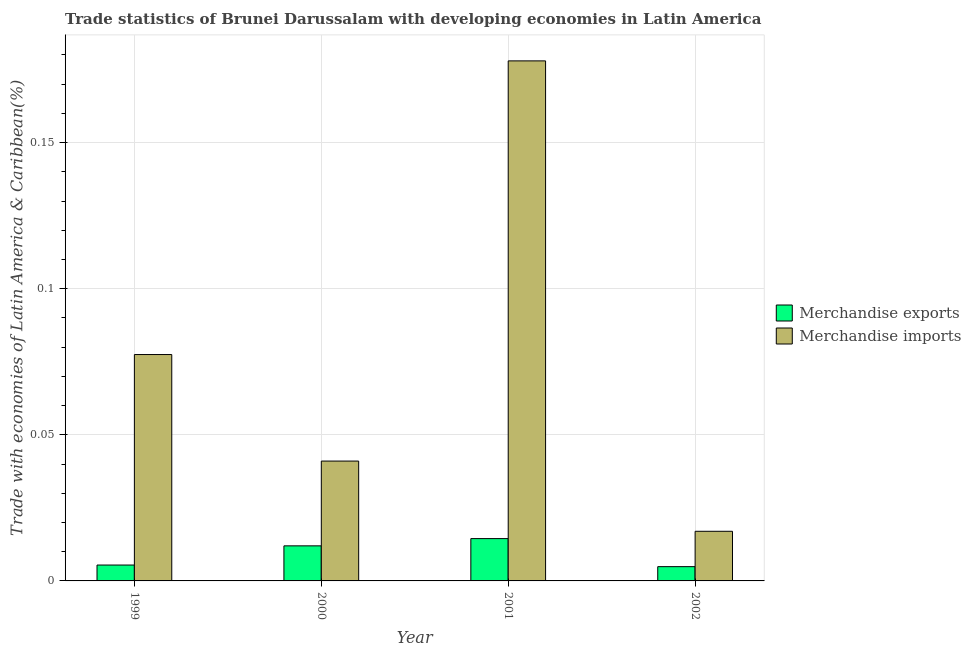How many groups of bars are there?
Give a very brief answer. 4. Are the number of bars per tick equal to the number of legend labels?
Offer a very short reply. Yes. How many bars are there on the 4th tick from the right?
Make the answer very short. 2. What is the label of the 1st group of bars from the left?
Your answer should be very brief. 1999. In how many cases, is the number of bars for a given year not equal to the number of legend labels?
Your response must be concise. 0. What is the merchandise imports in 1999?
Your answer should be very brief. 0.08. Across all years, what is the maximum merchandise exports?
Offer a very short reply. 0.01. Across all years, what is the minimum merchandise exports?
Your answer should be compact. 0. In which year was the merchandise exports minimum?
Give a very brief answer. 2002. What is the total merchandise exports in the graph?
Ensure brevity in your answer.  0.04. What is the difference between the merchandise exports in 2001 and that in 2002?
Provide a succinct answer. 0.01. What is the difference between the merchandise exports in 2001 and the merchandise imports in 1999?
Make the answer very short. 0.01. What is the average merchandise exports per year?
Ensure brevity in your answer.  0.01. In the year 2000, what is the difference between the merchandise imports and merchandise exports?
Provide a succinct answer. 0. In how many years, is the merchandise exports greater than 0.060000000000000005 %?
Keep it short and to the point. 0. What is the ratio of the merchandise imports in 1999 to that in 2000?
Ensure brevity in your answer.  1.89. Is the merchandise imports in 1999 less than that in 2001?
Your answer should be compact. Yes. Is the difference between the merchandise imports in 1999 and 2001 greater than the difference between the merchandise exports in 1999 and 2001?
Your answer should be very brief. No. What is the difference between the highest and the second highest merchandise exports?
Your answer should be compact. 0. What is the difference between the highest and the lowest merchandise imports?
Your response must be concise. 0.16. In how many years, is the merchandise imports greater than the average merchandise imports taken over all years?
Ensure brevity in your answer.  1. How many bars are there?
Ensure brevity in your answer.  8. Are all the bars in the graph horizontal?
Give a very brief answer. No. Are the values on the major ticks of Y-axis written in scientific E-notation?
Your response must be concise. No. Does the graph contain any zero values?
Offer a very short reply. No. Where does the legend appear in the graph?
Give a very brief answer. Center right. How many legend labels are there?
Make the answer very short. 2. What is the title of the graph?
Make the answer very short. Trade statistics of Brunei Darussalam with developing economies in Latin America. Does "Under-5(female)" appear as one of the legend labels in the graph?
Provide a succinct answer. No. What is the label or title of the X-axis?
Your response must be concise. Year. What is the label or title of the Y-axis?
Provide a succinct answer. Trade with economies of Latin America & Caribbean(%). What is the Trade with economies of Latin America & Caribbean(%) in Merchandise exports in 1999?
Your response must be concise. 0.01. What is the Trade with economies of Latin America & Caribbean(%) of Merchandise imports in 1999?
Offer a very short reply. 0.08. What is the Trade with economies of Latin America & Caribbean(%) of Merchandise exports in 2000?
Provide a succinct answer. 0.01. What is the Trade with economies of Latin America & Caribbean(%) in Merchandise imports in 2000?
Provide a succinct answer. 0.04. What is the Trade with economies of Latin America & Caribbean(%) in Merchandise exports in 2001?
Your response must be concise. 0.01. What is the Trade with economies of Latin America & Caribbean(%) of Merchandise imports in 2001?
Ensure brevity in your answer.  0.18. What is the Trade with economies of Latin America & Caribbean(%) of Merchandise exports in 2002?
Make the answer very short. 0. What is the Trade with economies of Latin America & Caribbean(%) of Merchandise imports in 2002?
Your response must be concise. 0.02. Across all years, what is the maximum Trade with economies of Latin America & Caribbean(%) in Merchandise exports?
Offer a terse response. 0.01. Across all years, what is the maximum Trade with economies of Latin America & Caribbean(%) of Merchandise imports?
Provide a short and direct response. 0.18. Across all years, what is the minimum Trade with economies of Latin America & Caribbean(%) in Merchandise exports?
Your answer should be very brief. 0. Across all years, what is the minimum Trade with economies of Latin America & Caribbean(%) of Merchandise imports?
Provide a succinct answer. 0.02. What is the total Trade with economies of Latin America & Caribbean(%) of Merchandise exports in the graph?
Provide a succinct answer. 0.04. What is the total Trade with economies of Latin America & Caribbean(%) of Merchandise imports in the graph?
Give a very brief answer. 0.31. What is the difference between the Trade with economies of Latin America & Caribbean(%) of Merchandise exports in 1999 and that in 2000?
Offer a very short reply. -0.01. What is the difference between the Trade with economies of Latin America & Caribbean(%) in Merchandise imports in 1999 and that in 2000?
Provide a short and direct response. 0.04. What is the difference between the Trade with economies of Latin America & Caribbean(%) of Merchandise exports in 1999 and that in 2001?
Offer a terse response. -0.01. What is the difference between the Trade with economies of Latin America & Caribbean(%) in Merchandise imports in 1999 and that in 2001?
Provide a short and direct response. -0.1. What is the difference between the Trade with economies of Latin America & Caribbean(%) of Merchandise exports in 1999 and that in 2002?
Your answer should be compact. 0. What is the difference between the Trade with economies of Latin America & Caribbean(%) in Merchandise imports in 1999 and that in 2002?
Provide a succinct answer. 0.06. What is the difference between the Trade with economies of Latin America & Caribbean(%) of Merchandise exports in 2000 and that in 2001?
Give a very brief answer. -0. What is the difference between the Trade with economies of Latin America & Caribbean(%) of Merchandise imports in 2000 and that in 2001?
Provide a succinct answer. -0.14. What is the difference between the Trade with economies of Latin America & Caribbean(%) in Merchandise exports in 2000 and that in 2002?
Provide a succinct answer. 0.01. What is the difference between the Trade with economies of Latin America & Caribbean(%) of Merchandise imports in 2000 and that in 2002?
Make the answer very short. 0.02. What is the difference between the Trade with economies of Latin America & Caribbean(%) in Merchandise exports in 2001 and that in 2002?
Provide a succinct answer. 0.01. What is the difference between the Trade with economies of Latin America & Caribbean(%) in Merchandise imports in 2001 and that in 2002?
Make the answer very short. 0.16. What is the difference between the Trade with economies of Latin America & Caribbean(%) in Merchandise exports in 1999 and the Trade with economies of Latin America & Caribbean(%) in Merchandise imports in 2000?
Keep it short and to the point. -0.04. What is the difference between the Trade with economies of Latin America & Caribbean(%) of Merchandise exports in 1999 and the Trade with economies of Latin America & Caribbean(%) of Merchandise imports in 2001?
Keep it short and to the point. -0.17. What is the difference between the Trade with economies of Latin America & Caribbean(%) in Merchandise exports in 1999 and the Trade with economies of Latin America & Caribbean(%) in Merchandise imports in 2002?
Your answer should be compact. -0.01. What is the difference between the Trade with economies of Latin America & Caribbean(%) in Merchandise exports in 2000 and the Trade with economies of Latin America & Caribbean(%) in Merchandise imports in 2001?
Ensure brevity in your answer.  -0.17. What is the difference between the Trade with economies of Latin America & Caribbean(%) of Merchandise exports in 2000 and the Trade with economies of Latin America & Caribbean(%) of Merchandise imports in 2002?
Provide a succinct answer. -0.01. What is the difference between the Trade with economies of Latin America & Caribbean(%) of Merchandise exports in 2001 and the Trade with economies of Latin America & Caribbean(%) of Merchandise imports in 2002?
Make the answer very short. -0. What is the average Trade with economies of Latin America & Caribbean(%) in Merchandise exports per year?
Ensure brevity in your answer.  0.01. What is the average Trade with economies of Latin America & Caribbean(%) in Merchandise imports per year?
Provide a short and direct response. 0.08. In the year 1999, what is the difference between the Trade with economies of Latin America & Caribbean(%) of Merchandise exports and Trade with economies of Latin America & Caribbean(%) of Merchandise imports?
Give a very brief answer. -0.07. In the year 2000, what is the difference between the Trade with economies of Latin America & Caribbean(%) of Merchandise exports and Trade with economies of Latin America & Caribbean(%) of Merchandise imports?
Provide a short and direct response. -0.03. In the year 2001, what is the difference between the Trade with economies of Latin America & Caribbean(%) in Merchandise exports and Trade with economies of Latin America & Caribbean(%) in Merchandise imports?
Keep it short and to the point. -0.16. In the year 2002, what is the difference between the Trade with economies of Latin America & Caribbean(%) of Merchandise exports and Trade with economies of Latin America & Caribbean(%) of Merchandise imports?
Ensure brevity in your answer.  -0.01. What is the ratio of the Trade with economies of Latin America & Caribbean(%) of Merchandise exports in 1999 to that in 2000?
Your answer should be compact. 0.45. What is the ratio of the Trade with economies of Latin America & Caribbean(%) in Merchandise imports in 1999 to that in 2000?
Your answer should be compact. 1.89. What is the ratio of the Trade with economies of Latin America & Caribbean(%) of Merchandise exports in 1999 to that in 2001?
Give a very brief answer. 0.38. What is the ratio of the Trade with economies of Latin America & Caribbean(%) of Merchandise imports in 1999 to that in 2001?
Offer a terse response. 0.44. What is the ratio of the Trade with economies of Latin America & Caribbean(%) of Merchandise exports in 1999 to that in 2002?
Provide a succinct answer. 1.11. What is the ratio of the Trade with economies of Latin America & Caribbean(%) of Merchandise imports in 1999 to that in 2002?
Ensure brevity in your answer.  4.56. What is the ratio of the Trade with economies of Latin America & Caribbean(%) of Merchandise exports in 2000 to that in 2001?
Make the answer very short. 0.83. What is the ratio of the Trade with economies of Latin America & Caribbean(%) in Merchandise imports in 2000 to that in 2001?
Your answer should be compact. 0.23. What is the ratio of the Trade with economies of Latin America & Caribbean(%) in Merchandise exports in 2000 to that in 2002?
Your answer should be compact. 2.46. What is the ratio of the Trade with economies of Latin America & Caribbean(%) of Merchandise imports in 2000 to that in 2002?
Keep it short and to the point. 2.42. What is the ratio of the Trade with economies of Latin America & Caribbean(%) in Merchandise exports in 2001 to that in 2002?
Your answer should be compact. 2.97. What is the ratio of the Trade with economies of Latin America & Caribbean(%) of Merchandise imports in 2001 to that in 2002?
Your response must be concise. 10.48. What is the difference between the highest and the second highest Trade with economies of Latin America & Caribbean(%) of Merchandise exports?
Make the answer very short. 0. What is the difference between the highest and the second highest Trade with economies of Latin America & Caribbean(%) of Merchandise imports?
Make the answer very short. 0.1. What is the difference between the highest and the lowest Trade with economies of Latin America & Caribbean(%) in Merchandise exports?
Your answer should be very brief. 0.01. What is the difference between the highest and the lowest Trade with economies of Latin America & Caribbean(%) in Merchandise imports?
Keep it short and to the point. 0.16. 